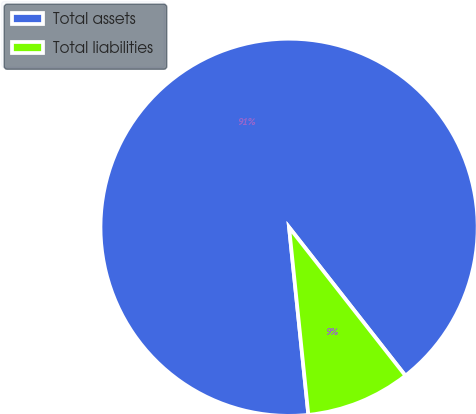<chart> <loc_0><loc_0><loc_500><loc_500><pie_chart><fcel>Total assets<fcel>Total liabilities<nl><fcel>91.05%<fcel>8.95%<nl></chart> 